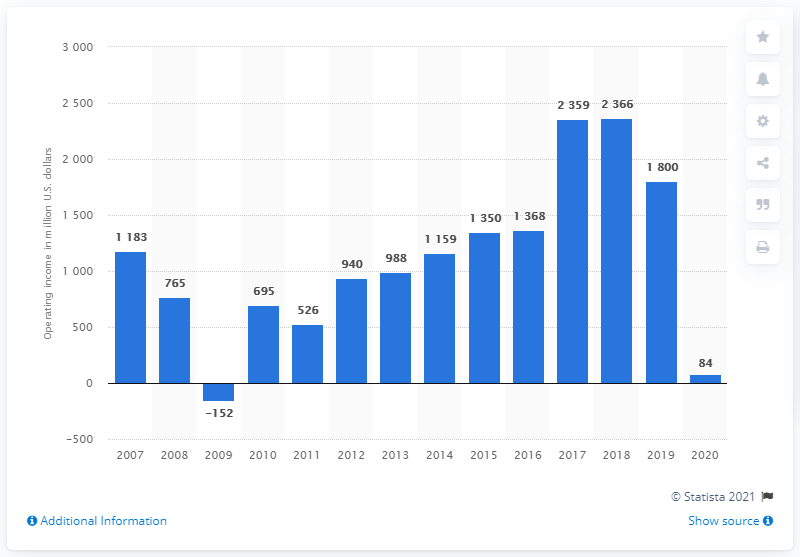Outline some significant characteristics in this image. Marriott's operating income in the previous year was 1800. In 2020, Marriott's operating income was approximately $84 million in dollars. 